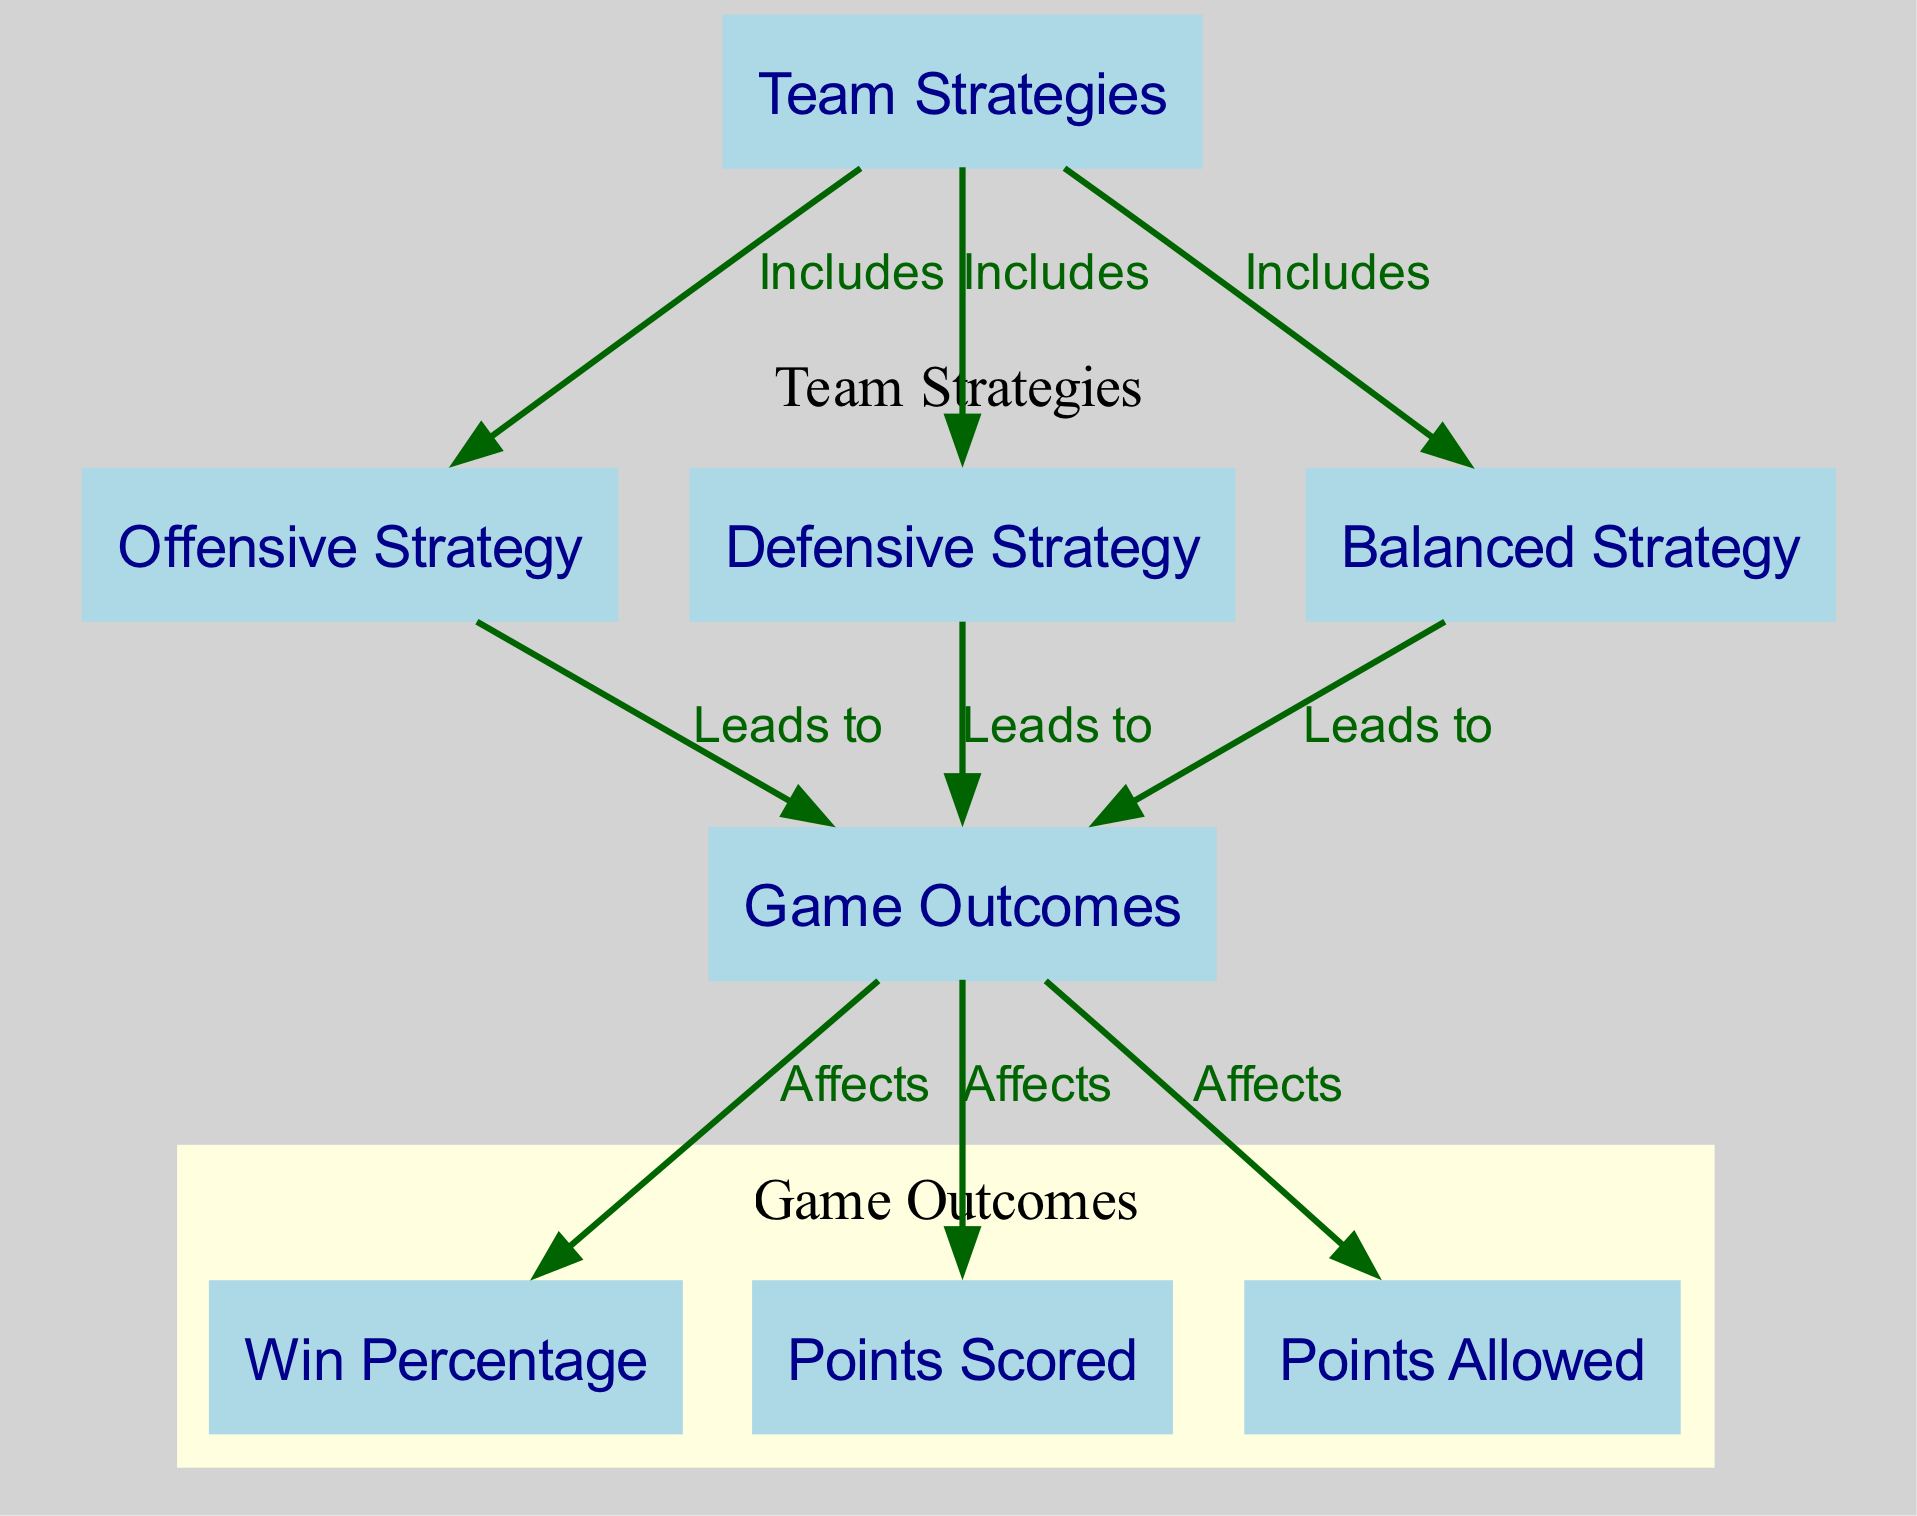What are the three types of team strategies? The diagram lists three types of team strategies: offensive strategy, defensive strategy, and balanced strategy, indicated as separate nodes under Team Strategies.
Answer: Offensive strategy, defensive strategy, balanced strategy What does an offensive strategy lead to? According to the diagram, the offensive strategy leads to game outcomes, as illustrated by the directed edge from offensive strategy to game outcomes.
Answer: Game outcomes How many nodes are in the diagram? The diagram contains eight nodes detailing team strategies and game outcomes, which are visualized as individual elements in the graph.
Answer: Eight What is affected by game outcomes? The diagram shows that game outcomes affect win percentage, points scored, and points allowed, as indicated by directed edges leading from game outcomes to these three nodes.
Answer: Win percentage, points scored, points allowed Which strategy is focused on preventing opponent scores? The defensive strategy is specifically categorized in the diagram under team strategies and is described as tactics focused on preventing opponent scores.
Answer: Defensive strategy Which strategy leads to a higher win percentage? To determine which strategy can lead to a higher win percentage, one must analyze the outcomes associated with each type; the diagram does not provide specific percentages, requiring further data for an exact answer.
Answer: Depends on context (not directly indicated) What is the relationship between game outcomes and points scored? The diagram illustrates that game outcomes affect points scored, conveyed through a directed edge from game outcomes to the points scored node, indicating a direct influence.
Answer: Affects How are the strategy nodes grouped in the diagram? The strategy nodes (offensive, defensive, balanced) are grouped under the label 'Team Strategies' in a subgraph, which visually clusters these related concepts together.
Answer: Under 'Team Strategies' cluster What two outcomes are associated with the balanced strategy? The balanced strategy leads to game outcomes, which subsequently affect both win percentage and points scored, demonstrating its relationship with these outcomes in the diagram.
Answer: Game outcomes (affecting win percentage and points scored) 